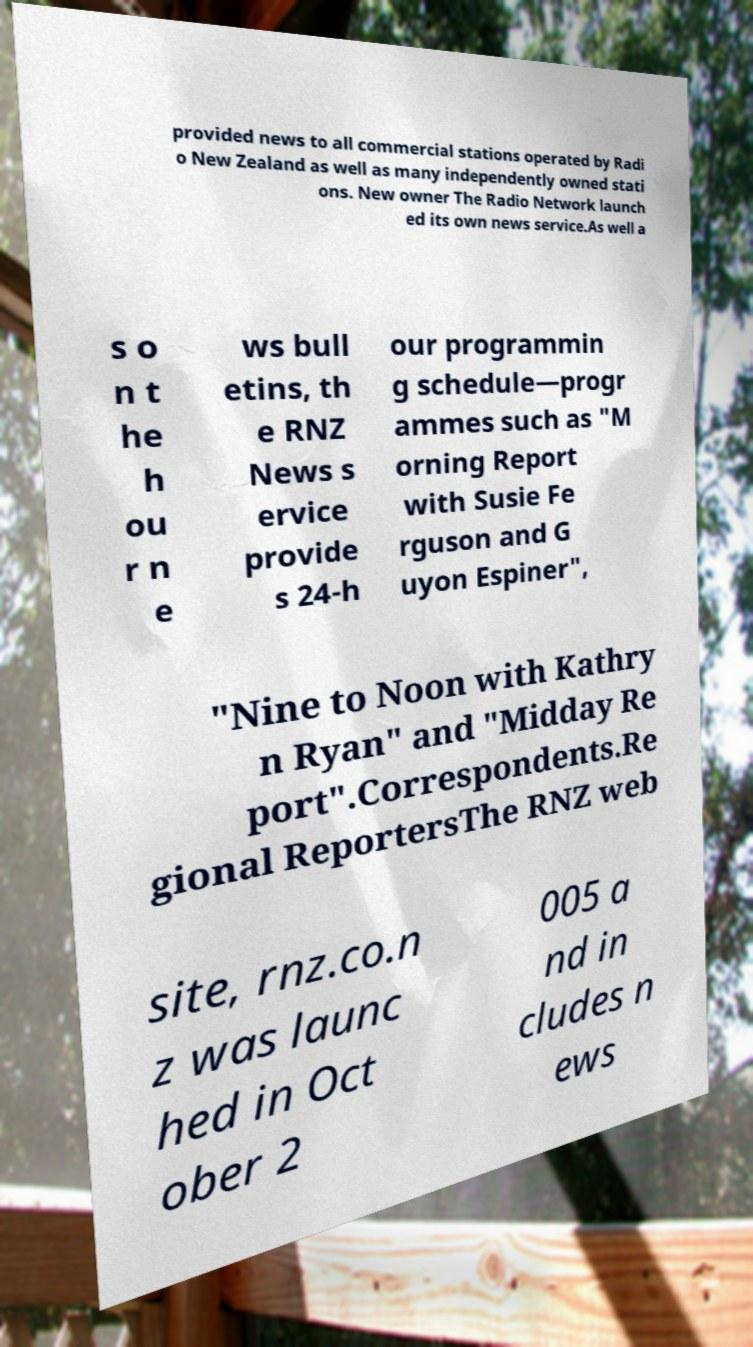I need the written content from this picture converted into text. Can you do that? provided news to all commercial stations operated by Radi o New Zealand as well as many independently owned stati ons. New owner The Radio Network launch ed its own news service.As well a s o n t he h ou r n e ws bull etins, th e RNZ News s ervice provide s 24-h our programmin g schedule—progr ammes such as "M orning Report with Susie Fe rguson and G uyon Espiner", "Nine to Noon with Kathry n Ryan" and "Midday Re port".Correspondents.Re gional ReportersThe RNZ web site, rnz.co.n z was launc hed in Oct ober 2 005 a nd in cludes n ews 